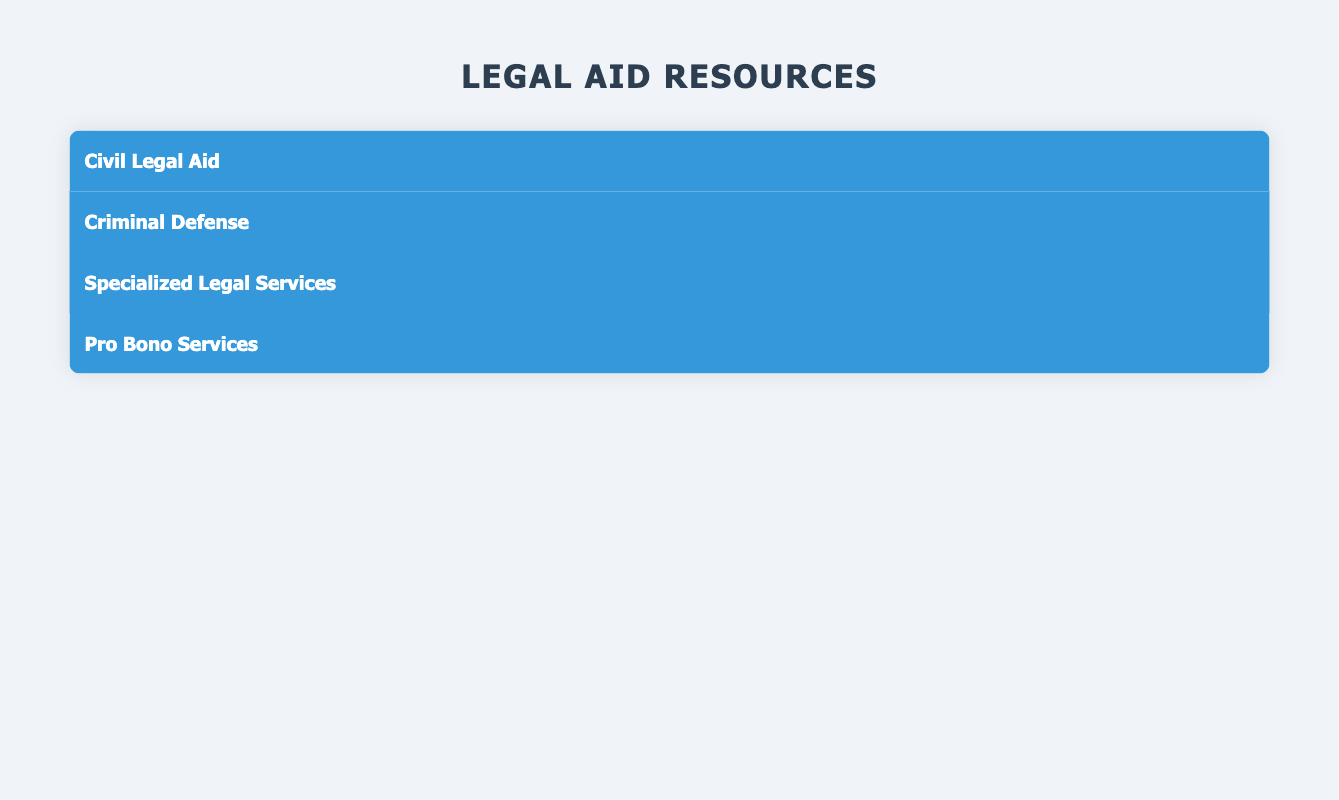What types of legal aid are available in the table? The table presents four types of legal aid resources: Civil Legal Aid, Criminal Defense, Specialized Legal Services, and Pro Bono Services. Each type serves specific areas and has corresponding organizations.
Answer: Civil Legal Aid, Criminal Defense, Specialized Legal Services, Pro Bono Services Which organization provides housing and immigration services in New York City? According to the table, the Legal Aid Society of New York offers housing and immigration services in New York City. This organization is specifically listed under the Civil Legal Aid type.
Answer: Legal Aid Society of New York How many organizations offer criminal defense services? The table lists two organizations under the Criminal Defense type: the Public Defender Service for the District of Columbia and the California Public Defender Association. Therefore, there are a total of 2 organizations.
Answer: 2 Is there an organization that provides immigration law services in Los Angeles? The table does not list any organizations specifically providing immigration law services in Los Angeles. The organizations that provide immigration law services listed in the table serve on a national scale, not specifically in Los Angeles.
Answer: No Which services are offered by the Greater Boston Legal Services? The Greater Boston Legal Services provides the following services: Housing, Public Benefits, and Family Law. This information is contained in the Civil Legal Aid section of the table.
Answer: Housing, Public Benefits, Family Law Which area is served by the Volunteer Lawyers Network and what services do they provide? The Volunteer Lawyers Network serves Minneapolis, MN, and provides services related to Family Law, Housing, and Consumer Issues, as detailed in the Pro Bono Services section of the table.
Answer: Minneapolis, MN; Family Law, Housing, Consumer Issues If you combine all the services offered by organizations in Civil Legal Aid, how many unique service categories can you identify? The Civil Legal Aid section lists two organizations with the following services: Legal Aid Society of New York (Housing, Immigration, Family Law, Consumer Protection) and Greater Boston Legal Services (Housing, Public Benefits, Family Law). Consolidating these, we identify unique categories: Housing, Immigration, Family Law, Consumer Protection, and Public Benefits, totaling 5 unique services.
Answer: 5 unique services Does the ACLU provide any services related to criminal defense? The ACLU does not provide services specifically related to criminal defense; it focuses on Civil Rights, Free Speech, and Privacy. Thus, the statement is false based on the data given.
Answer: No 